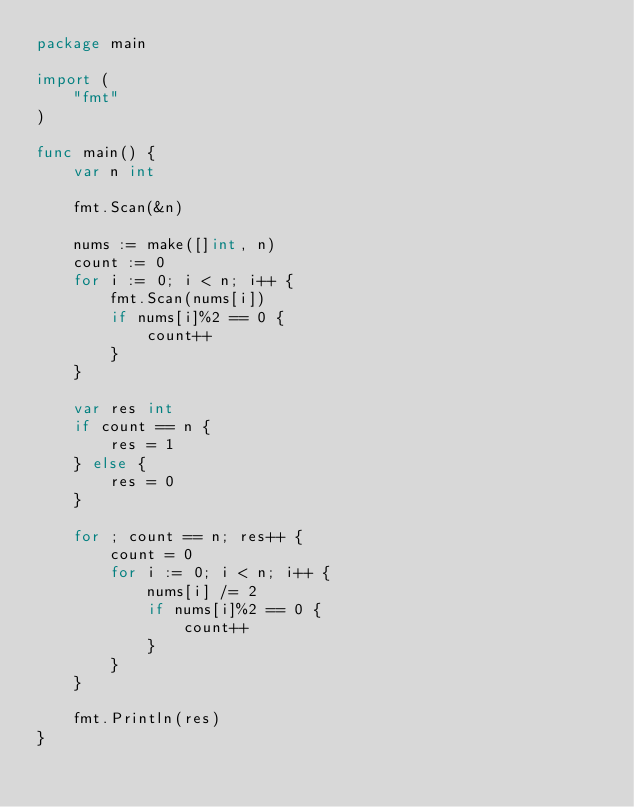<code> <loc_0><loc_0><loc_500><loc_500><_Go_>package main

import (
	"fmt"
)

func main() {
	var n int

	fmt.Scan(&n)

	nums := make([]int, n)
	count := 0
	for i := 0; i < n; i++ {
		fmt.Scan(nums[i])
		if nums[i]%2 == 0 {
			count++
		}
	}

	var res int
	if count == n {
		res = 1
	} else {
		res = 0
	}

	for ; count == n; res++ {
		count = 0
		for i := 0; i < n; i++ {
			nums[i] /= 2
			if nums[i]%2 == 0 {
				count++
			}
		}
	}

	fmt.Println(res)
}
</code> 